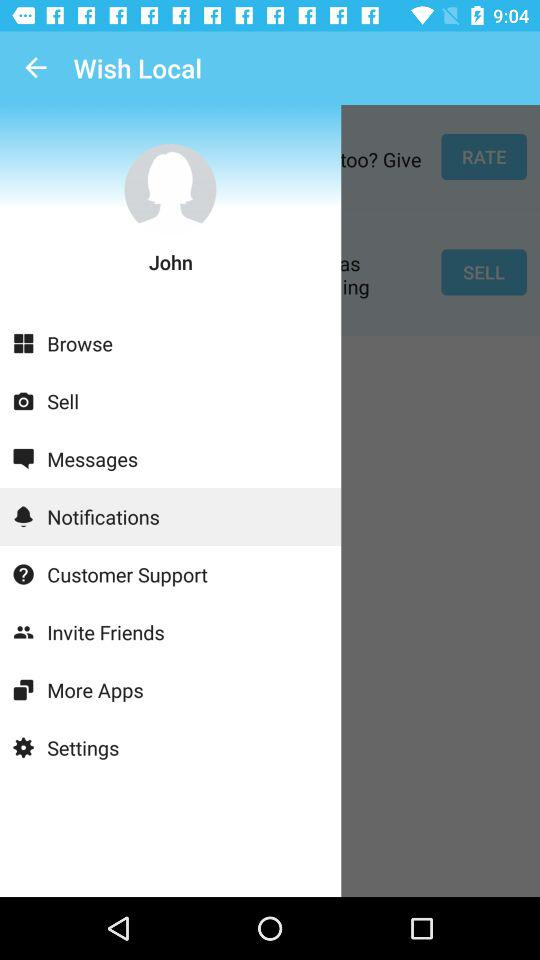Which tab is currently selected? The tab currently selected is "Notifications". 